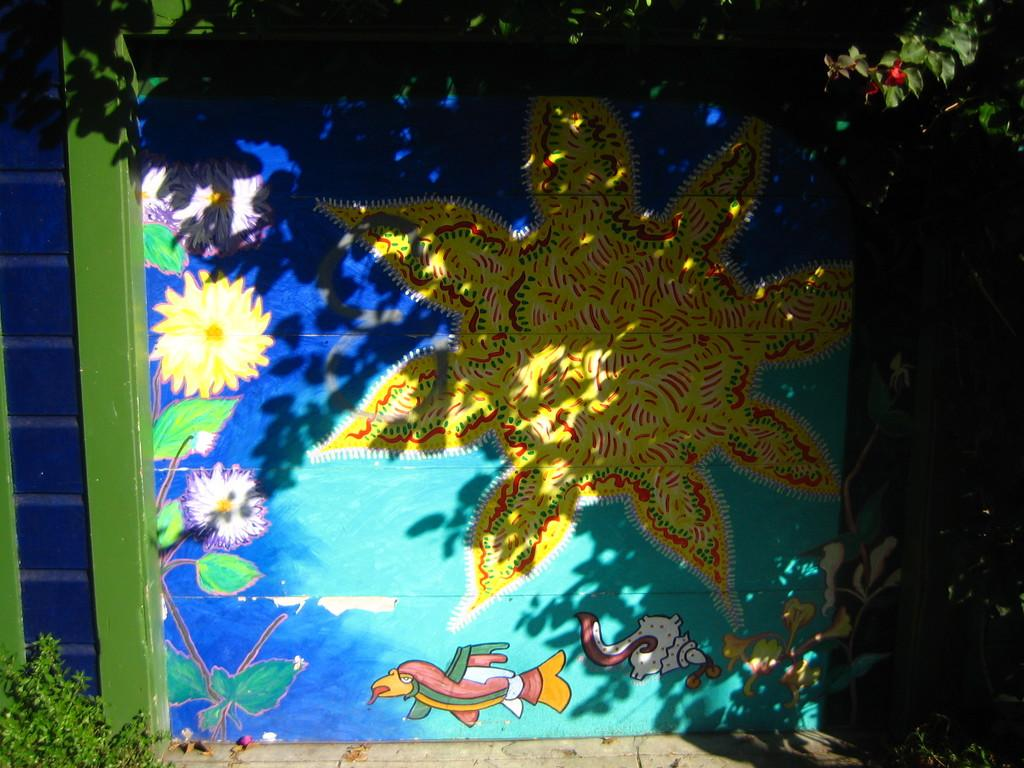What colors are used on the wall in the image? The wall in the image is blue and green colored. What is on the wall in the image? There is a painting on the wall in the image. What colors are present in the painting? The painting has yellow, green, white, red, and blue colors. What can be seen below the wall in the image? There is ground visible in the image. What type of vegetation is present in the image? There are trees in the image. Can you see any donkeys walking through the cave in the image? There is no cave or donkey present in the image. How many ants are crawling on the painting in the image? There are no ants visible in the image. 